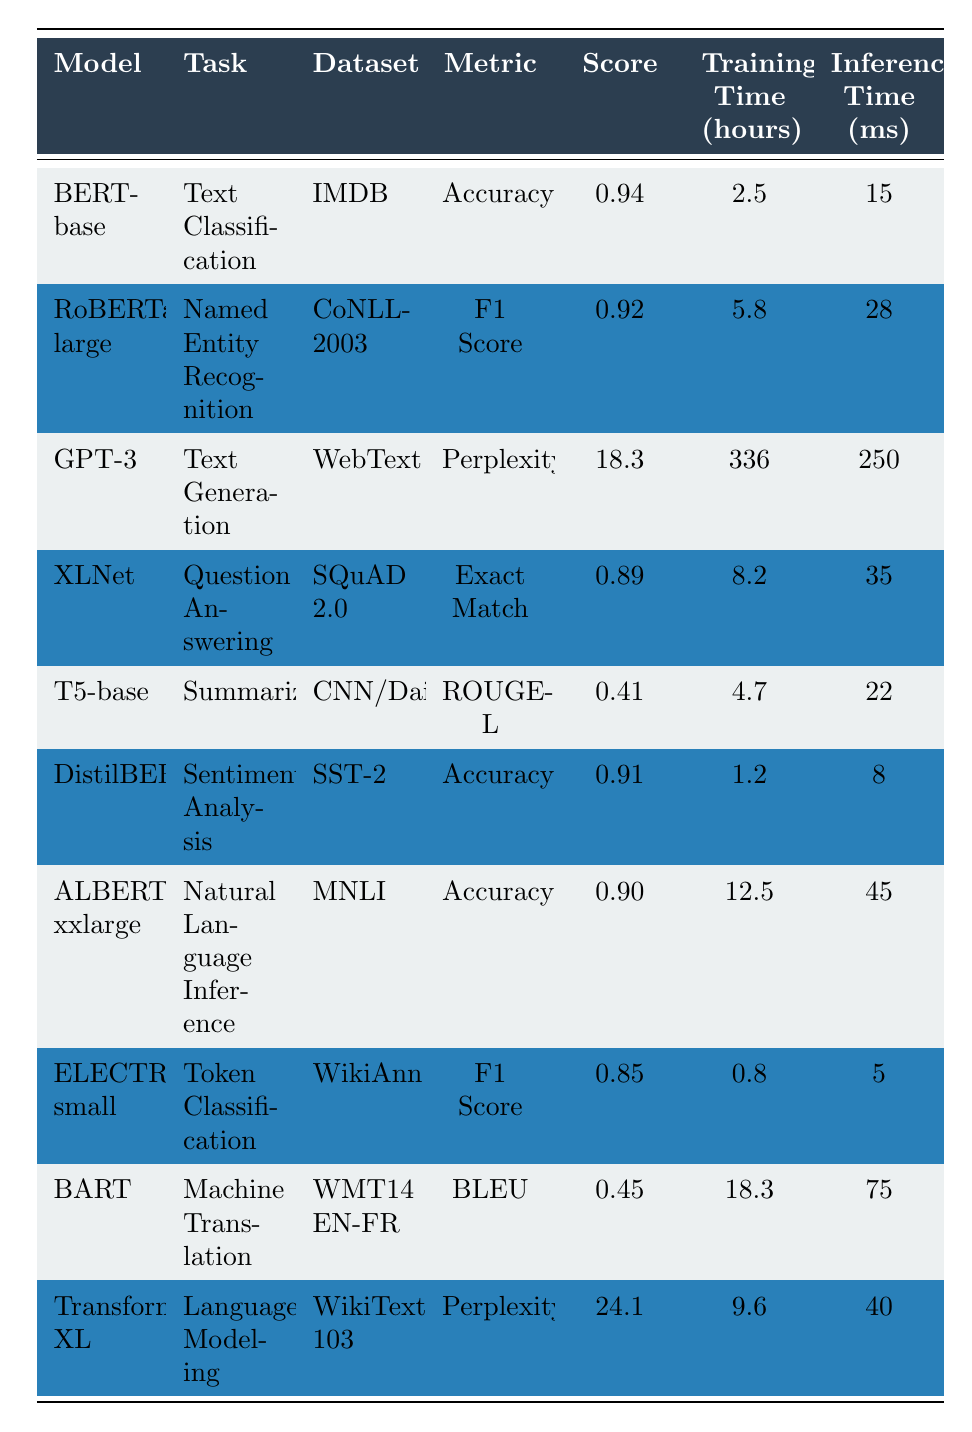What is the accuracy score of the BERT-base model? The table shows the accuracy score of the BERT-base model under the "Score" column for the task of text classification. The value listed is 0.94.
Answer: 0.94 Which model has the longest training time? By examining the "Training Time (hours)" column, we see that GPT-3 has the highest training time at 336 hours.
Answer: GPT-3 What is the F1 Score for ELECTRA-small? The F1 Score for ELECTRA-small is found in the "Score" column under its respective task. The value is 0.85.
Answer: 0.85 Is the inference time for the RoBERTa-large greater than that for DistilBERT? The inference times are 28 ms for RoBERTa-large and 8 ms for DistilBERT. Since 28 is greater than 8, the statement is true.
Answer: Yes What is the average training time of all models listed? To find the average, we sum the training times: (2.5 + 5.8 + 336 + 8.2 + 4.7 + 1.2 + 12.5 + 0.8 + 18.3 + 9.6) = 399.6 hours. There are 10 models, so the average is 399.6 / 10 = 39.96 hours.
Answer: 39.96 Which model has the best performance based on the accuracy metric? The highest accuracy score in the table is for the BERT-base model, with a score of 0.94.
Answer: BERT-base How many models have an inference time less than 10 ms? By checking the "Inference Time (ms)" column, we see that ELECTRA-small (5 ms) and DistilBERT (8 ms) have inference times below 10 ms. This is a total of 2 models.
Answer: 2 What is the difference in accuracy between DistilBERT and ALBERT-xxlarge? DistilBERT has an accuracy of 0.91 while ALBERT-xxlarge has an accuracy of 0.90. The difference is 0.91 - 0.90 = 0.01.
Answer: 0.01 Which model has the lowest ROUGE-L score? In the "Score" column, T5-base has the lowest ROUGE-L score of 0.41, which is lower than the scores for the other models.
Answer: T5-base If we combine the F1 Scores from RoBERTa-large and ELECTRA-small, what is the total? The F1 Score for RoBERTa-large is 0.92 and for ELECTRA-small it is 0.85. Totaling these gives 0.92 + 0.85 = 1.77.
Answer: 1.77 